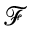Convert formula to latex. <formula><loc_0><loc_0><loc_500><loc_500>\mathcal { F }</formula> 